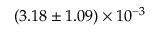Convert formula to latex. <formula><loc_0><loc_0><loc_500><loc_500>( 3 . 1 8 \pm 1 . 0 9 ) \times 1 0 ^ { - 3 }</formula> 